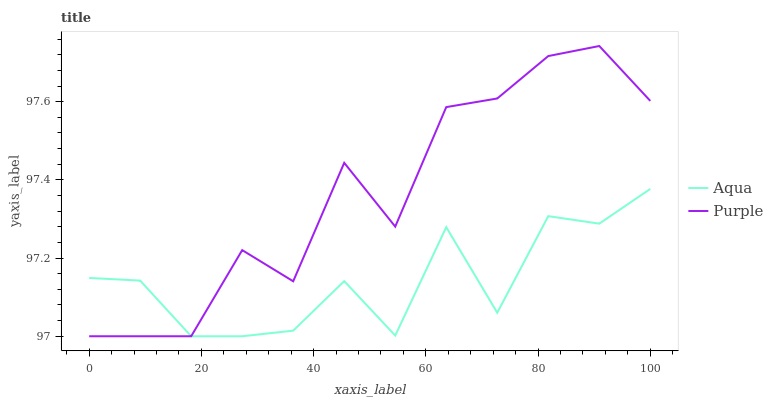Does Aqua have the minimum area under the curve?
Answer yes or no. Yes. Does Purple have the maximum area under the curve?
Answer yes or no. Yes. Does Aqua have the maximum area under the curve?
Answer yes or no. No. Is Aqua the smoothest?
Answer yes or no. Yes. Is Purple the roughest?
Answer yes or no. Yes. Is Aqua the roughest?
Answer yes or no. No. Does Purple have the lowest value?
Answer yes or no. Yes. Does Purple have the highest value?
Answer yes or no. Yes. Does Aqua have the highest value?
Answer yes or no. No. Does Aqua intersect Purple?
Answer yes or no. Yes. Is Aqua less than Purple?
Answer yes or no. No. Is Aqua greater than Purple?
Answer yes or no. No. 